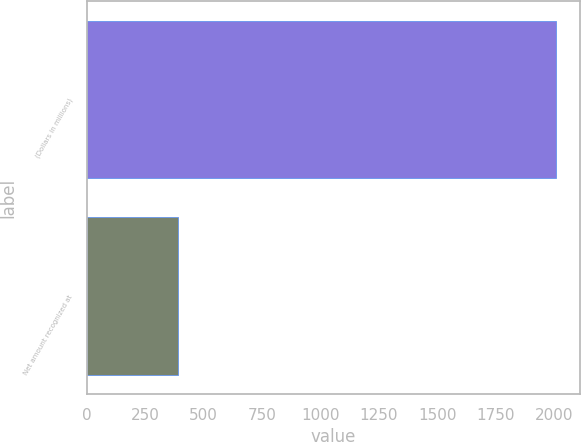Convert chart. <chart><loc_0><loc_0><loc_500><loc_500><bar_chart><fcel>(Dollars in millions)<fcel>Net amount recognized at<nl><fcel>2010<fcel>389<nl></chart> 